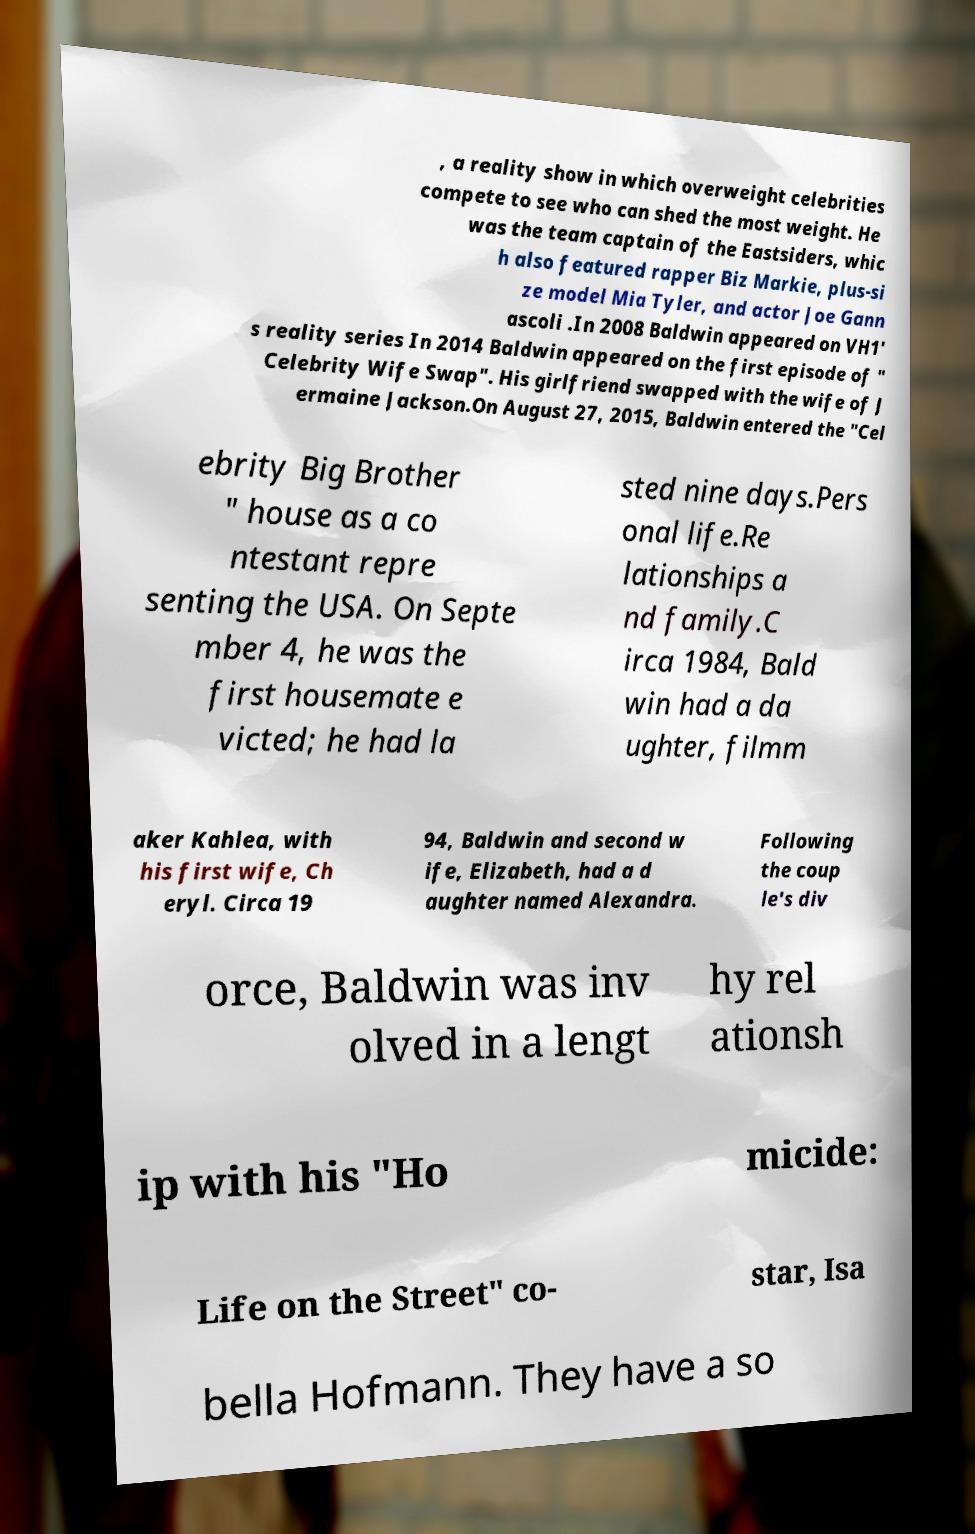I need the written content from this picture converted into text. Can you do that? , a reality show in which overweight celebrities compete to see who can shed the most weight. He was the team captain of the Eastsiders, whic h also featured rapper Biz Markie, plus-si ze model Mia Tyler, and actor Joe Gann ascoli .In 2008 Baldwin appeared on VH1' s reality series In 2014 Baldwin appeared on the first episode of " Celebrity Wife Swap". His girlfriend swapped with the wife of J ermaine Jackson.On August 27, 2015, Baldwin entered the "Cel ebrity Big Brother " house as a co ntestant repre senting the USA. On Septe mber 4, he was the first housemate e victed; he had la sted nine days.Pers onal life.Re lationships a nd family.C irca 1984, Bald win had a da ughter, filmm aker Kahlea, with his first wife, Ch eryl. Circa 19 94, Baldwin and second w ife, Elizabeth, had a d aughter named Alexandra. Following the coup le's div orce, Baldwin was inv olved in a lengt hy rel ationsh ip with his "Ho micide: Life on the Street" co- star, Isa bella Hofmann. They have a so 